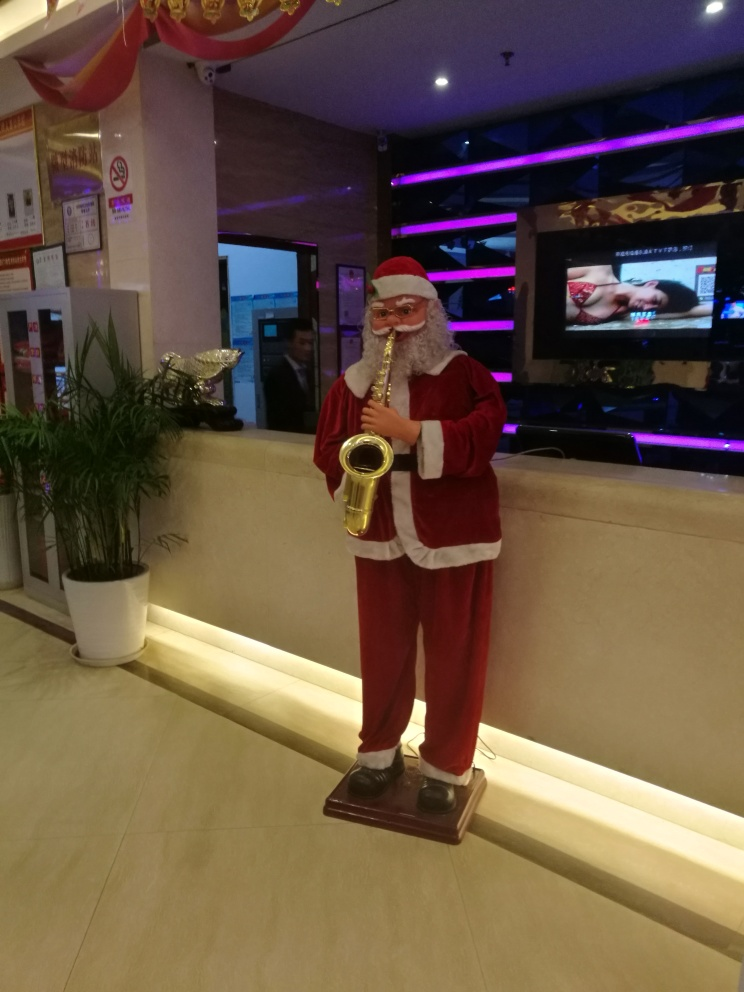Can you describe the main subject of the image? The main subject appears to be a santaclaustatic stature dressed in the traditional red and white attire, holding what seems to be a saxophone. The statue is positioned in an indoor environment, likely a lobby or entrance area given the appearance of a reception desk in the background. 